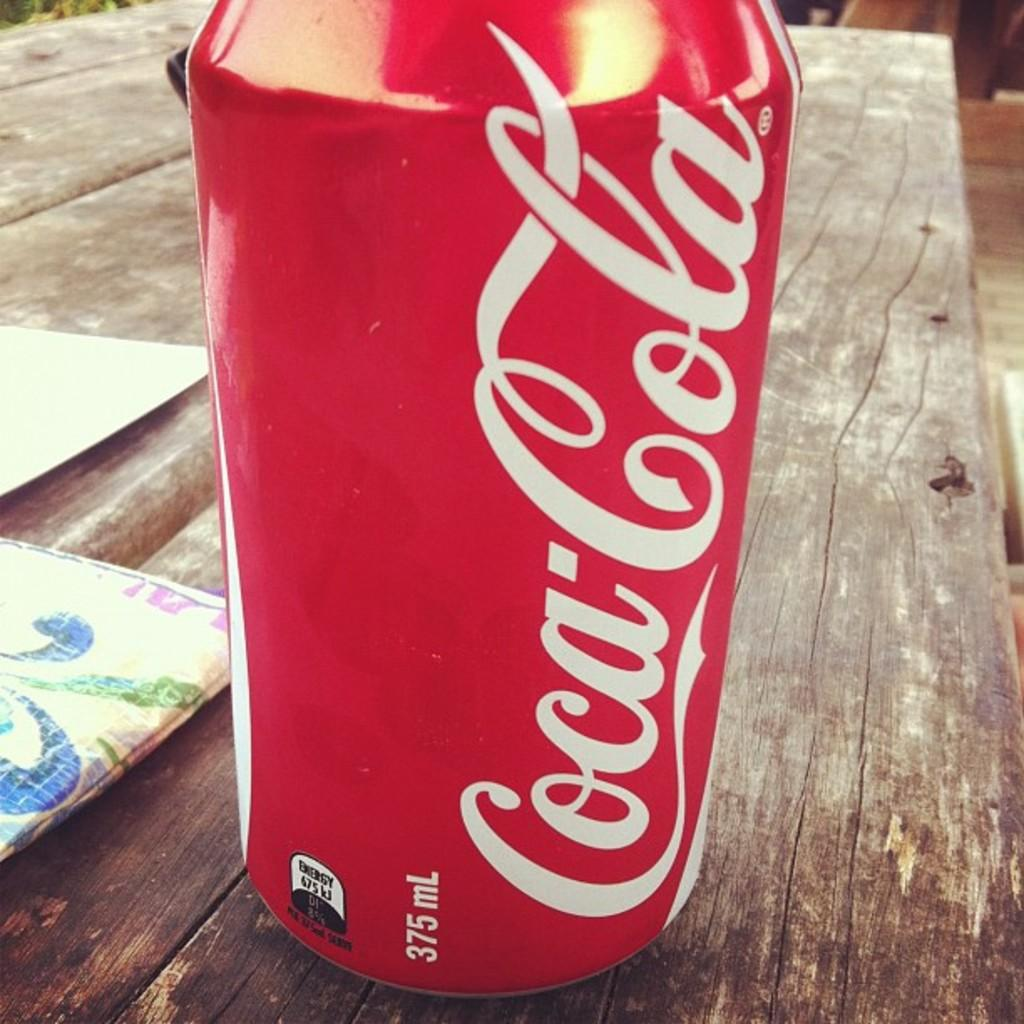<image>
Share a concise interpretation of the image provided. A red can with white letters that says Coca-Cola sits on a picnic table. 